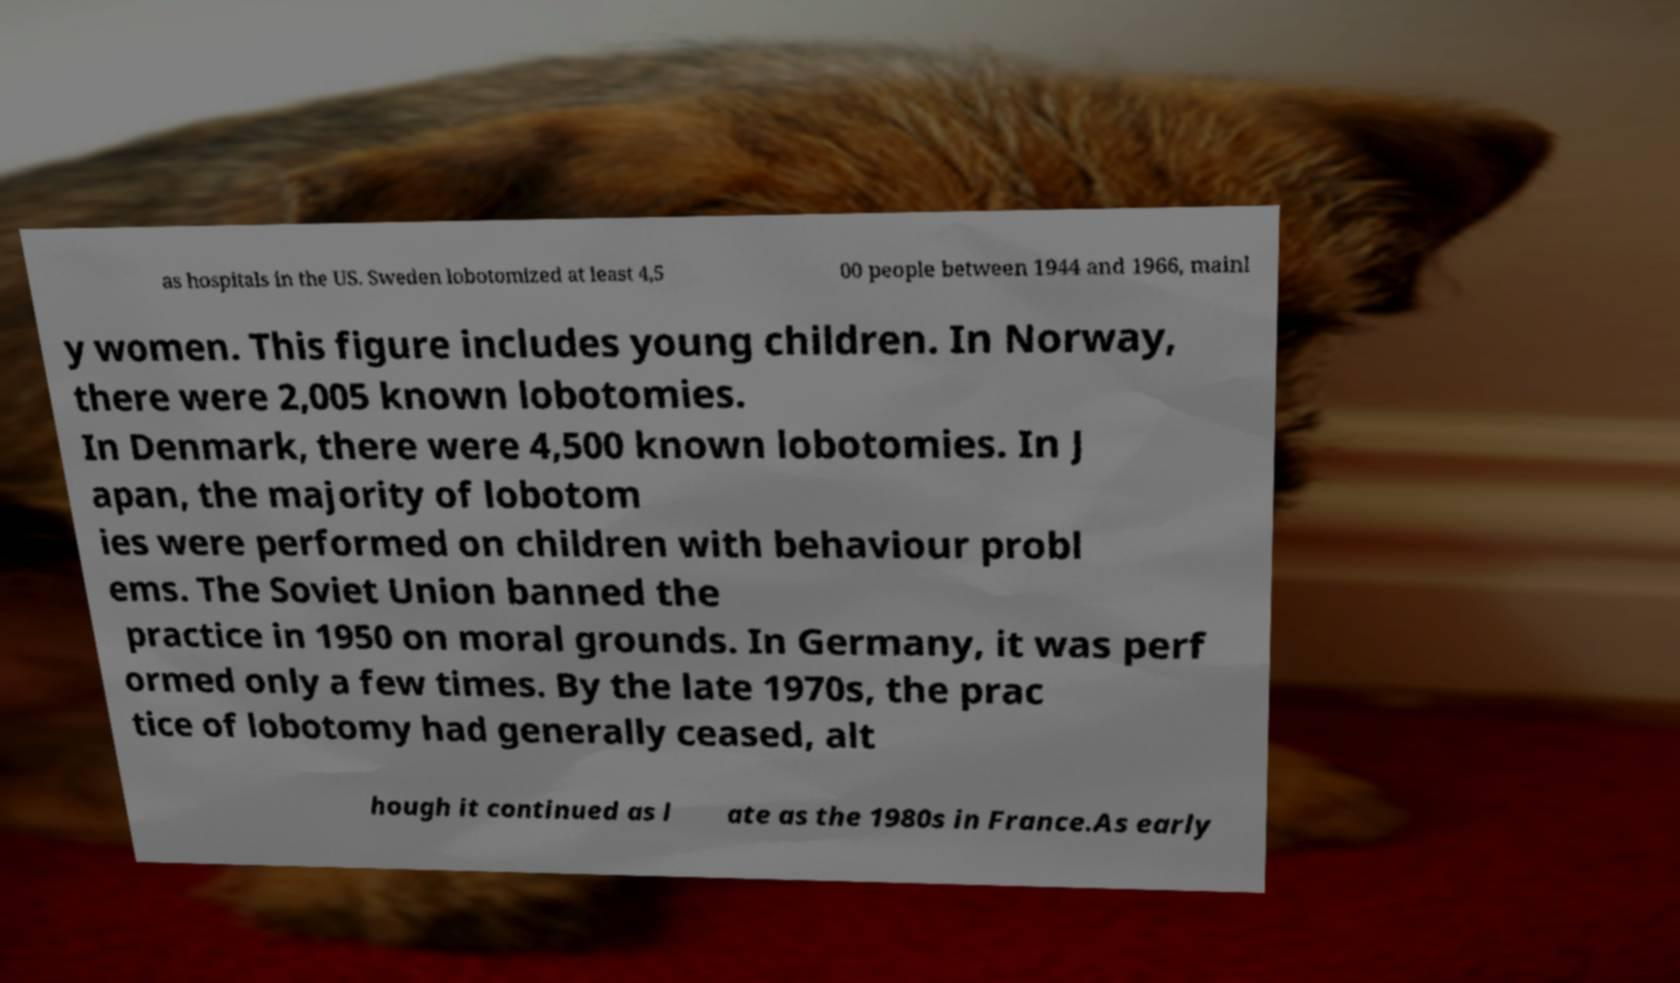What messages or text are displayed in this image? I need them in a readable, typed format. as hospitals in the US. Sweden lobotomized at least 4,5 00 people between 1944 and 1966, mainl y women. This figure includes young children. In Norway, there were 2,005 known lobotomies. In Denmark, there were 4,500 known lobotomies. In J apan, the majority of lobotom ies were performed on children with behaviour probl ems. The Soviet Union banned the practice in 1950 on moral grounds. In Germany, it was perf ormed only a few times. By the late 1970s, the prac tice of lobotomy had generally ceased, alt hough it continued as l ate as the 1980s in France.As early 